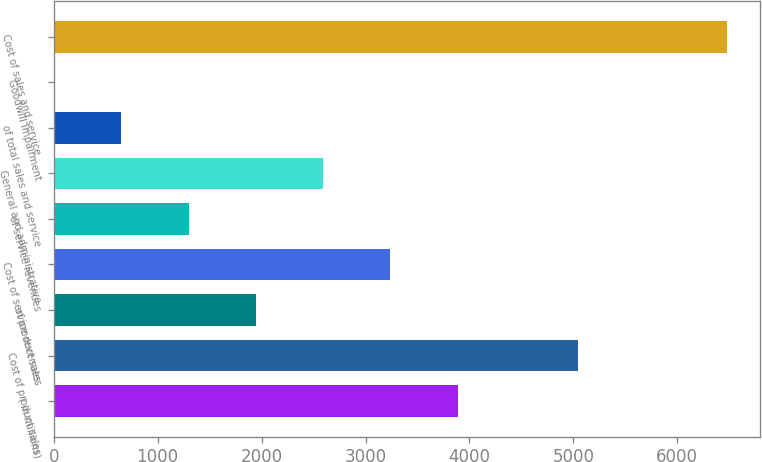<chart> <loc_0><loc_0><loc_500><loc_500><bar_chart><fcel>( in millions)<fcel>Cost of product sales<fcel>of product sales<fcel>Cost of service revenues<fcel>of service revenues<fcel>General and administrative<fcel>of total sales and service<fcel>Goodwill impairment<fcel>Cost of sales and service<nl><fcel>3886.94<fcel>5042<fcel>1945.91<fcel>3239.93<fcel>1298.9<fcel>2592.92<fcel>651.89<fcel>4.88<fcel>6475<nl></chart> 